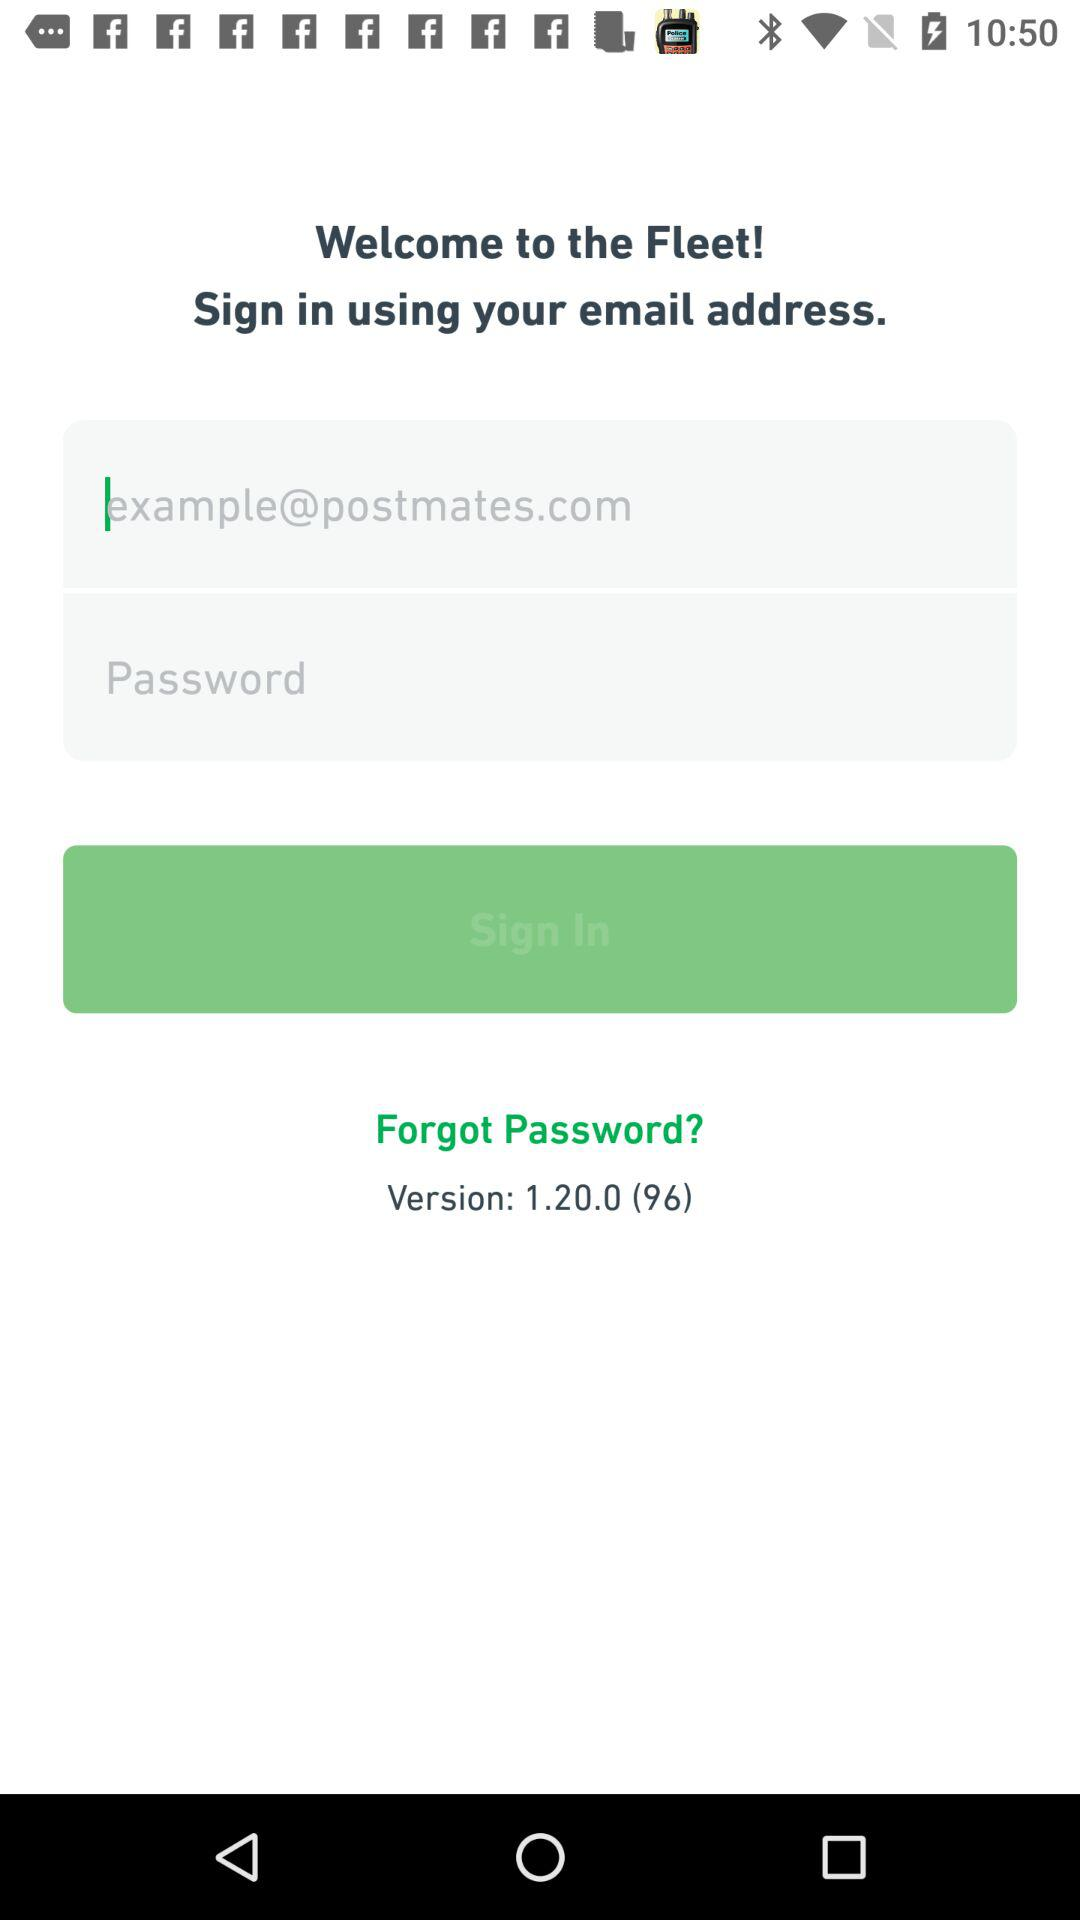What are the requirements to get a sign-in? To sign in, an email address is required. 